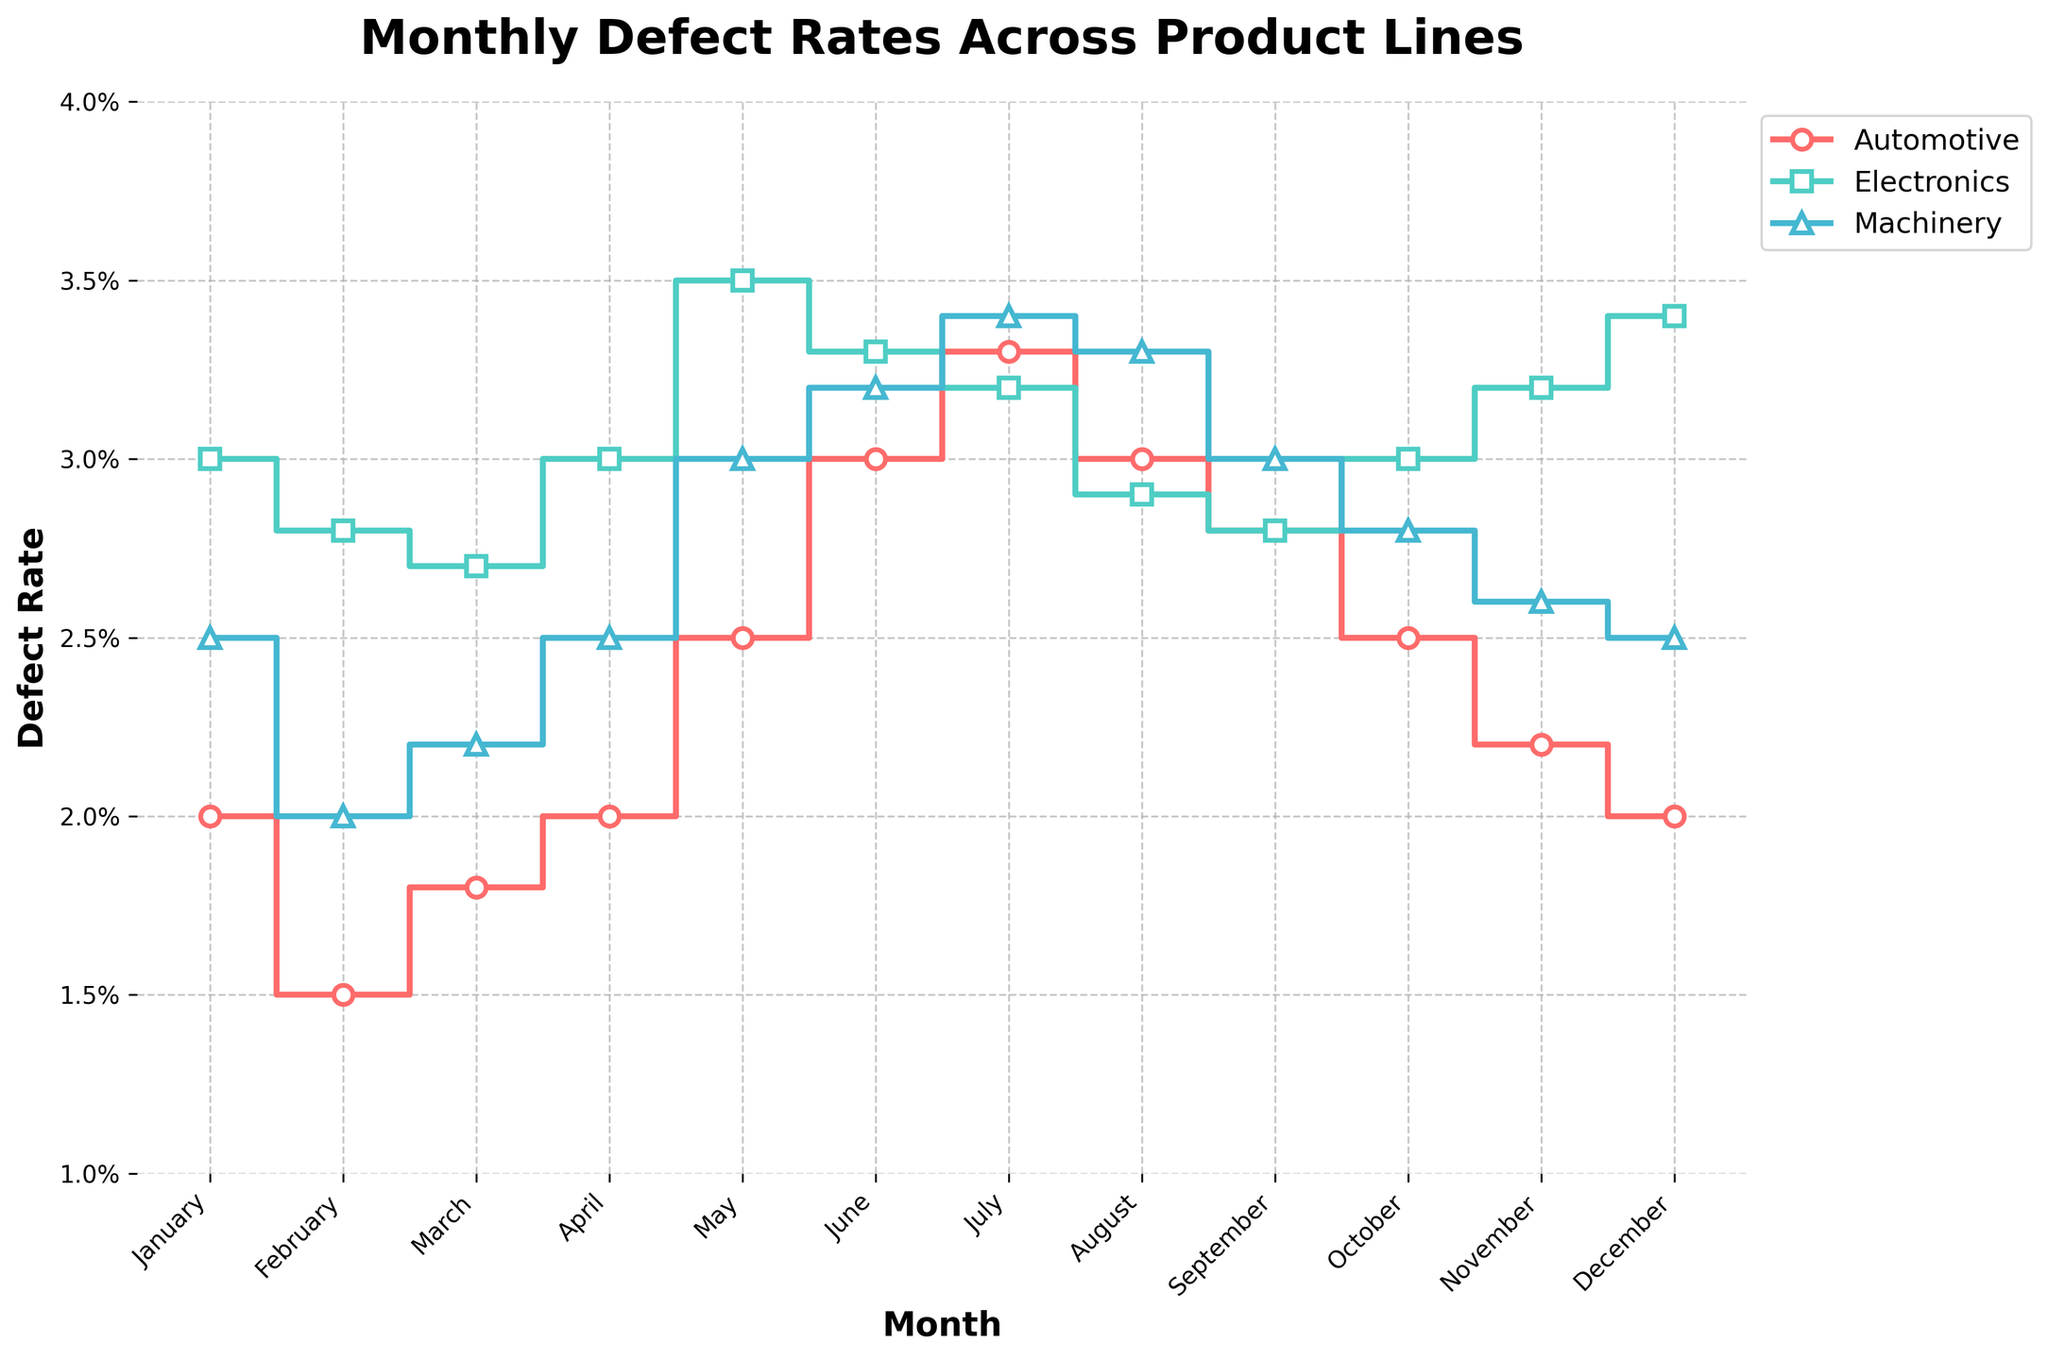What's the title of the plot? The title is generally located at the top of the plot, describing the main topic or data visualized. In this case, we can find "Monthly Defect Rates Across Product Lines" as the title.
Answer: Monthly Defect Rates Across Product Lines What months are shown on the x-axis? The x-axis represents the time period covered in the data. Here, the labels include 12 distinct months from "January" to "December".
Answer: January to December What are the defect rate ranges shown on the y-axis? The y-axis represents the defect rates. The plot uses a range from 0.01 to 0.04 to display defect rates, as indicated by the y-axis tick marks.
Answer: 0.01 to 0.04 Which product line shows the highest defect rate, and in which month did that occur? By examining the plot, we look for the data points that reach the highest value on the y-axis. For the Electronics product line, December shows the highest defect rate at 0.034.
Answer: Electronics, December What is the overall trend of defect rates for the Automotive product line throughout the year? Observing the steps of the plot line for Automotive, the defect rate starts at 0.02 in January, slightly decreases, rises gradually till July, slightly falls in August and September, then stabilizes from October through December, resulting in an overall mild increase and then slight stabilization.
Answer: Mild increase then stabilization In which month do all product lines show their lowest defect rate? We need to identify the month where each product line has its lowest value and see if there is a common month among all. For Automotive, February has the lowest rate at 0.015. For Electronics, March has 0.027, and for Machinery, February has 0.02. No single month has all the lowest rates.
Answer: No single month Compare the defect rate of the Machinery product line in June and July. Which month had a higher rate? By finding the defect rates for Machinery in June (0.032) and July (0.034), we can determine that July has a higher rate.
Answer: July What can be inferred about the seasonality of defect rates in the Electronics product line? By analyzing the pattern of the steps in the plot for Electronics, defect rates tend to rise in May, slightly decrease in August, then start to rise again till December, indicating a seasonal variation with potential peaks in spring and at the end of the year.
Answer: Seasonal peaks in spring and end of the year 